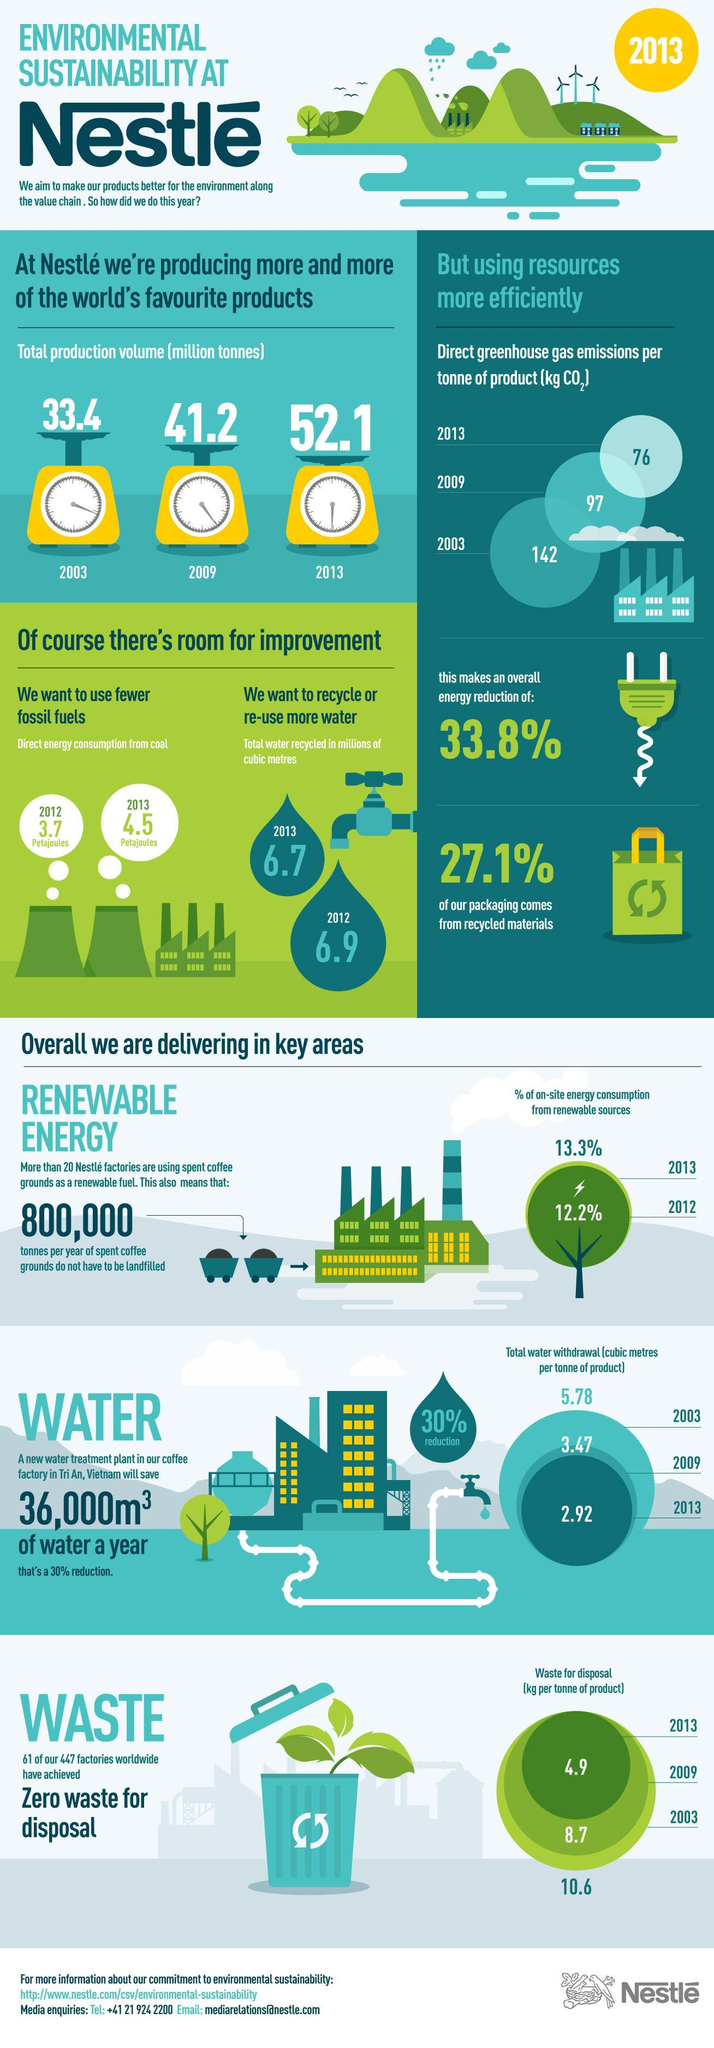What percentage of nestle packaging comes from non-recycled materials?
Answer the question with a short phrase. 72.9% What is the amount of direct greenhouse gas emissions per tonne of Nestle products (kg CO2) in 2013? 76 What is the amount of waste for disposal in Kg per tonne of nestle product in 2009? 8.7 What is the total water withdrawal in cubic metres per tonne of nestle products in 2013? 2.92 What percentage of on-site energy consumption of Nestle factories are from renewable sources in 2012? 12.2% What is the total production volume (in million tonnes) of Nestle in 2009? 41.2 What is the total amount of water recycled (in million cubic metres) in nestle factories in 2012? 6.9 